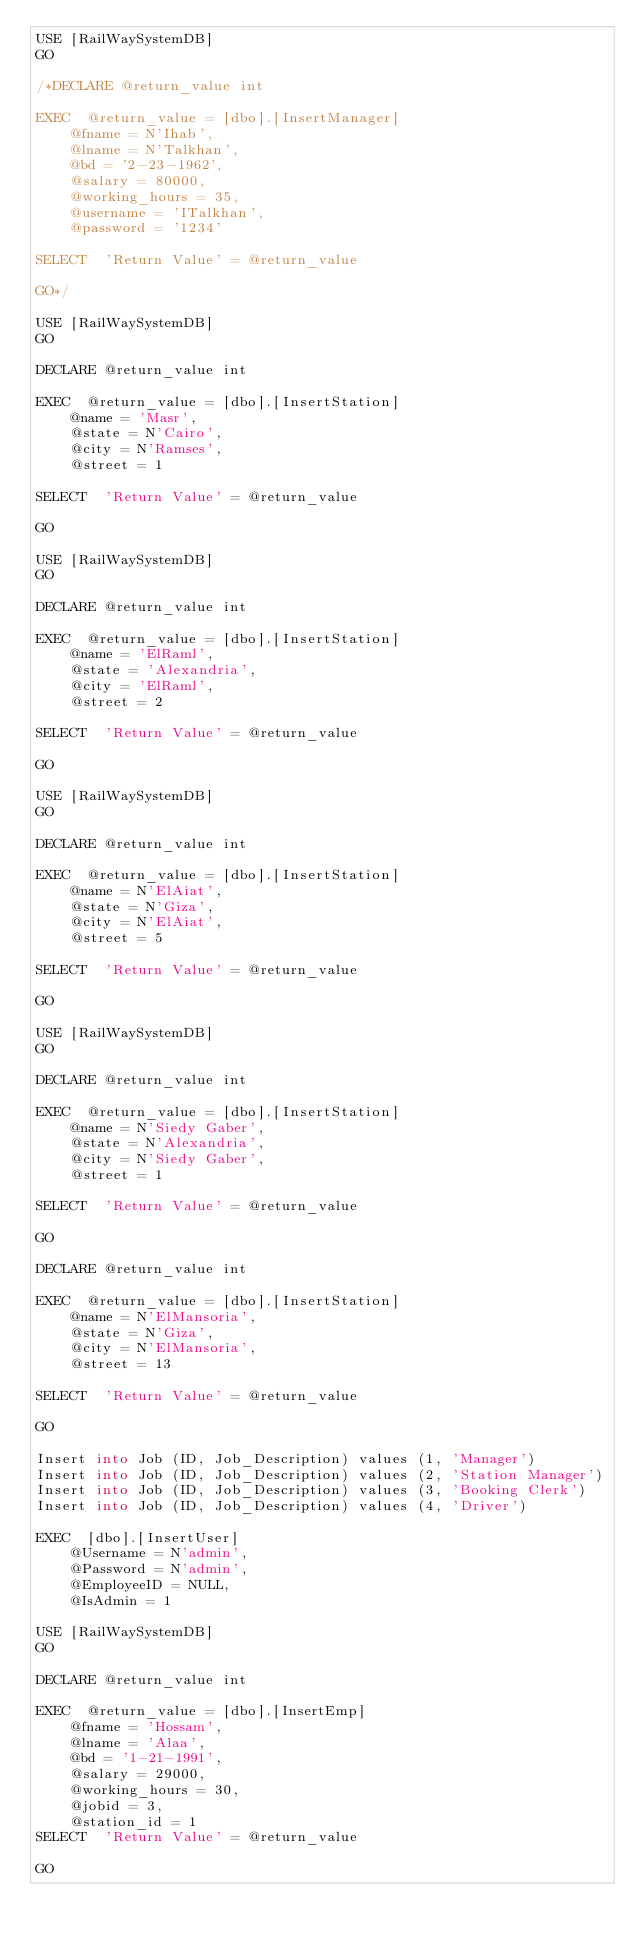Convert code to text. <code><loc_0><loc_0><loc_500><loc_500><_SQL_>USE [RailWaySystemDB]
GO

/*DECLARE	@return_value int

EXEC	@return_value = [dbo].[InsertManager]
		@fname = N'Ihab',
		@lname = N'Talkhan',
		@bd = '2-23-1962',
		@salary = 80000,
		@working_hours = 35,
		@username = 'ITalkhan',
		@password = '1234'

SELECT	'Return Value' = @return_value

GO*/

USE [RailWaySystemDB]
GO

DECLARE	@return_value int

EXEC	@return_value = [dbo].[InsertStation]
		@name = 'Masr',
		@state = N'Cairo',
		@city = N'Ramses',
		@street = 1

SELECT	'Return Value' = @return_value

GO

USE [RailWaySystemDB]
GO

DECLARE	@return_value int

EXEC	@return_value = [dbo].[InsertStation]
		@name = 'ElRaml',
		@state = 'Alexandria',
		@city = 'ElRaml',
		@street = 2

SELECT	'Return Value' = @return_value

GO

USE [RailWaySystemDB]
GO

DECLARE	@return_value int

EXEC	@return_value = [dbo].[InsertStation]
		@name = N'ElAiat',
		@state = N'Giza',
		@city = N'ElAiat',
		@street = 5

SELECT	'Return Value' = @return_value

GO

USE [RailWaySystemDB]
GO

DECLARE	@return_value int

EXEC	@return_value = [dbo].[InsertStation]
		@name = N'Siedy Gaber',
		@state = N'Alexandria',
		@city = N'Siedy Gaber',
		@street = 1

SELECT	'Return Value' = @return_value

GO

DECLARE	@return_value int

EXEC	@return_value = [dbo].[InsertStation]
		@name = N'ElMansoria',
		@state = N'Giza',
		@city = N'ElMansoria',
		@street = 13

SELECT	'Return Value' = @return_value

GO

Insert into Job (ID, Job_Description) values (1, 'Manager')
Insert into Job (ID, Job_Description) values (2, 'Station Manager')
Insert into Job (ID, Job_Description) values (3, 'Booking Clerk')
Insert into Job (ID, Job_Description) values (4, 'Driver')

EXEC	[dbo].[InsertUser]
		@Username = N'admin',
		@Password = N'admin',
		@EmployeeID = NULL,
		@IsAdmin = 1

USE [RailWaySystemDB]
GO

DECLARE	@return_value int

EXEC	@return_value = [dbo].[InsertEmp]
		@fname = 'Hossam',
		@lname = 'Alaa',
		@bd = '1-21-1991',
		@salary = 29000,
		@working_hours = 30,
		@jobid = 3,
		@station_id = 1
SELECT	'Return Value' = @return_value

GO

</code> 